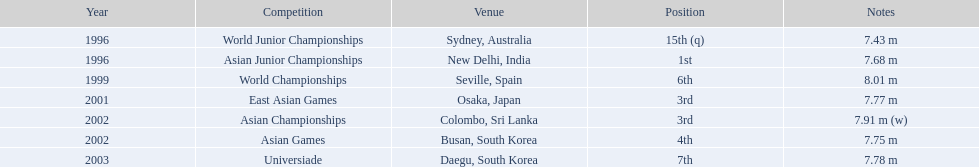In which events did huang le participate? World Junior Championships, Asian Junior Championships, World Championships, East Asian Games, Asian Championships, Asian Games, Universiade. What were the lengths he reached in those events? 7.43 m, 7.68 m, 8.01 m, 7.77 m, 7.91 m (w), 7.75 m, 7.78 m. Out of those lengths, which one was the greatest? 7.91 m (w). 